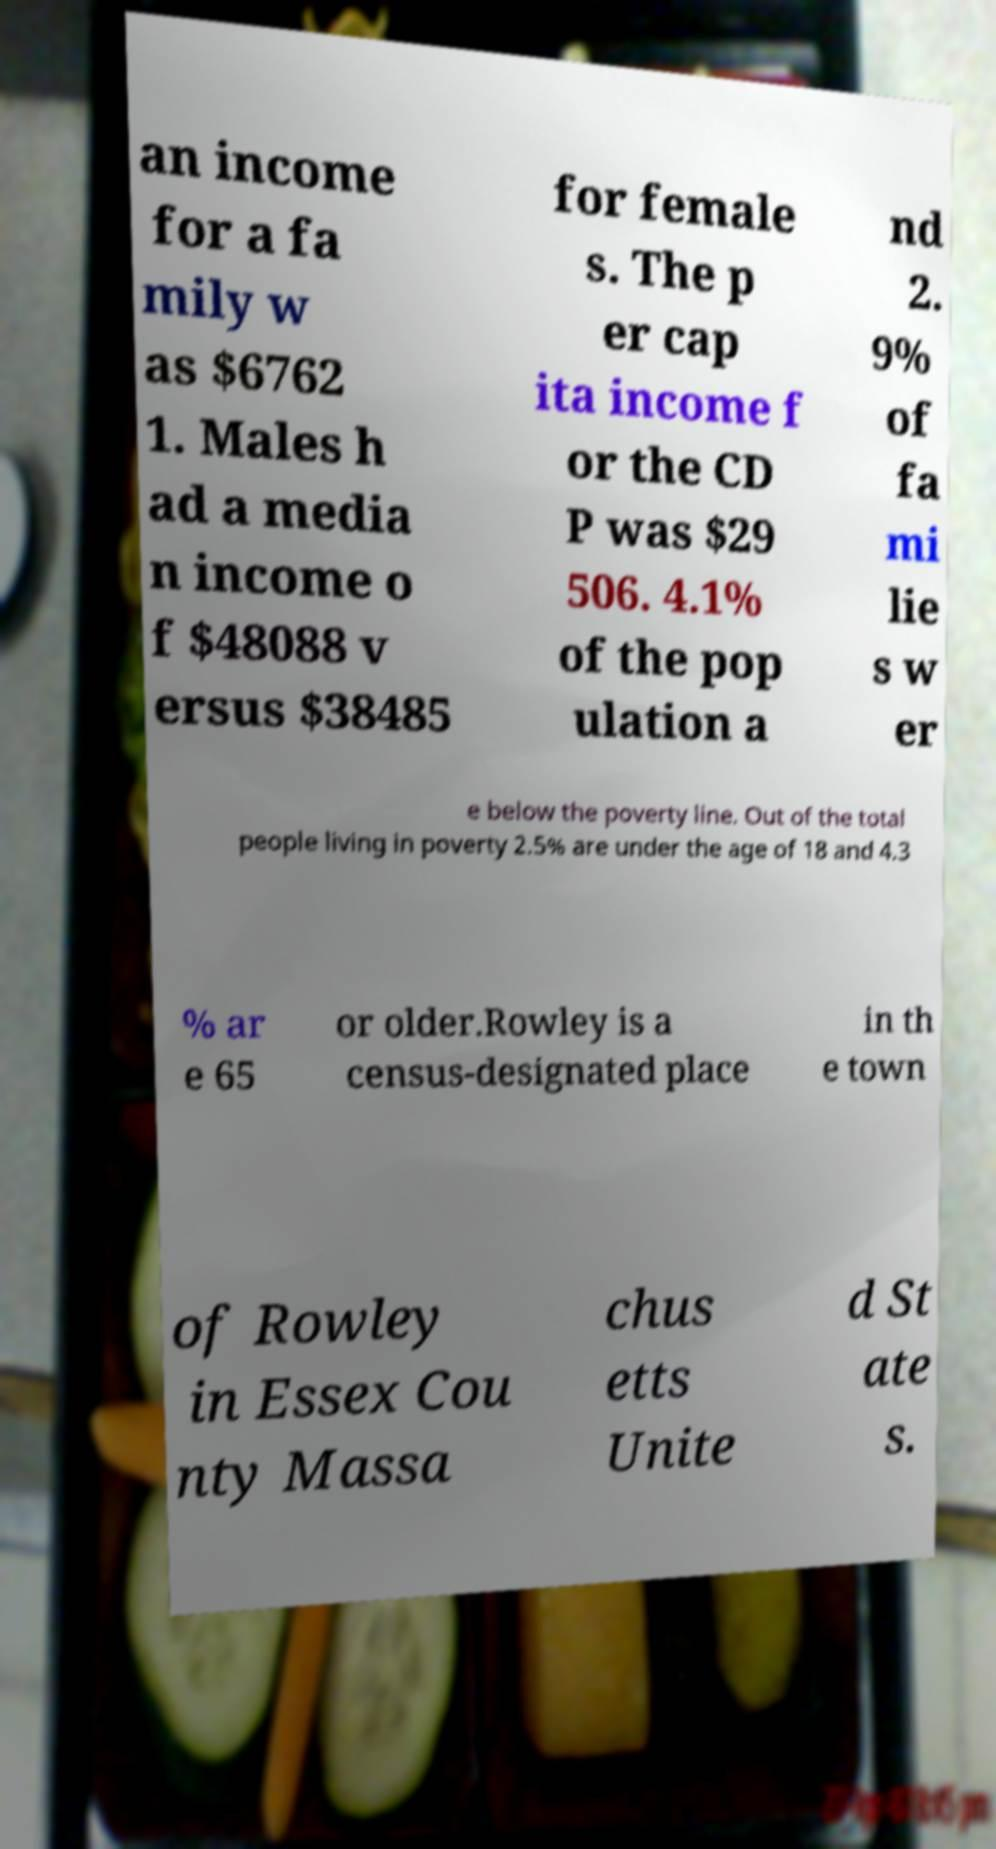For documentation purposes, I need the text within this image transcribed. Could you provide that? an income for a fa mily w as $6762 1. Males h ad a media n income o f $48088 v ersus $38485 for female s. The p er cap ita income f or the CD P was $29 506. 4.1% of the pop ulation a nd 2. 9% of fa mi lie s w er e below the poverty line. Out of the total people living in poverty 2.5% are under the age of 18 and 4.3 % ar e 65 or older.Rowley is a census-designated place in th e town of Rowley in Essex Cou nty Massa chus etts Unite d St ate s. 